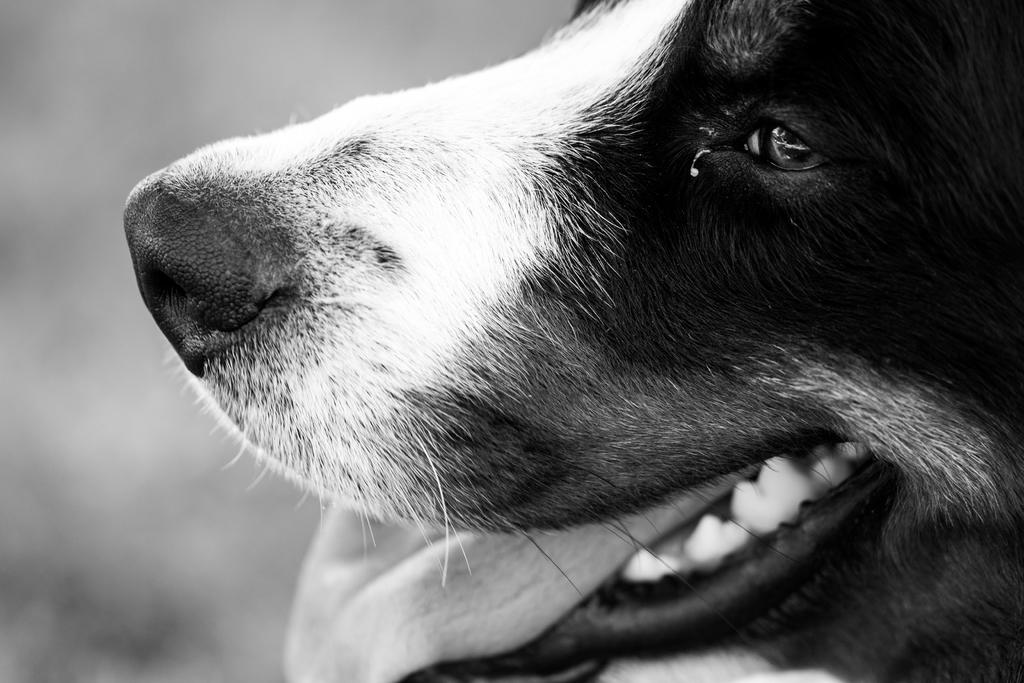What animal is in the image? There is a dog in the image. Where is the dog located in the image? The dog is in the center of the image. What colors are present on the dog? The dog is black and white in color. What type of bone is the dog holding in the image? There is no bone present in the image; the dog is not holding anything. 